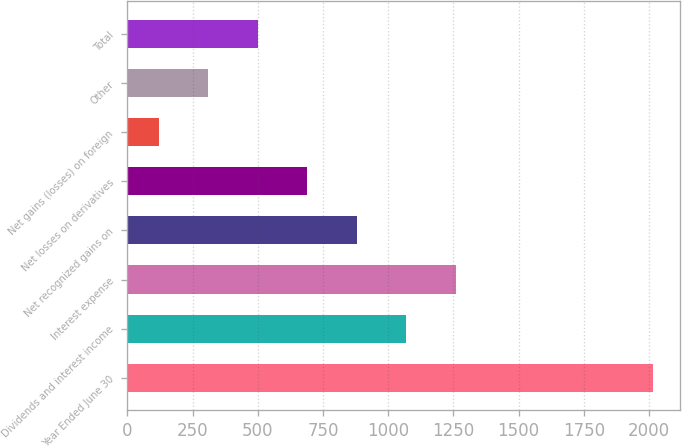Convert chart to OTSL. <chart><loc_0><loc_0><loc_500><loc_500><bar_chart><fcel>Year Ended June 30<fcel>Dividends and interest income<fcel>Interest expense<fcel>Net recognized gains on<fcel>Net losses on derivatives<fcel>Net gains (losses) on foreign<fcel>Other<fcel>Total<nl><fcel>2016<fcel>1068.5<fcel>1258<fcel>879<fcel>689.5<fcel>121<fcel>310.5<fcel>500<nl></chart> 